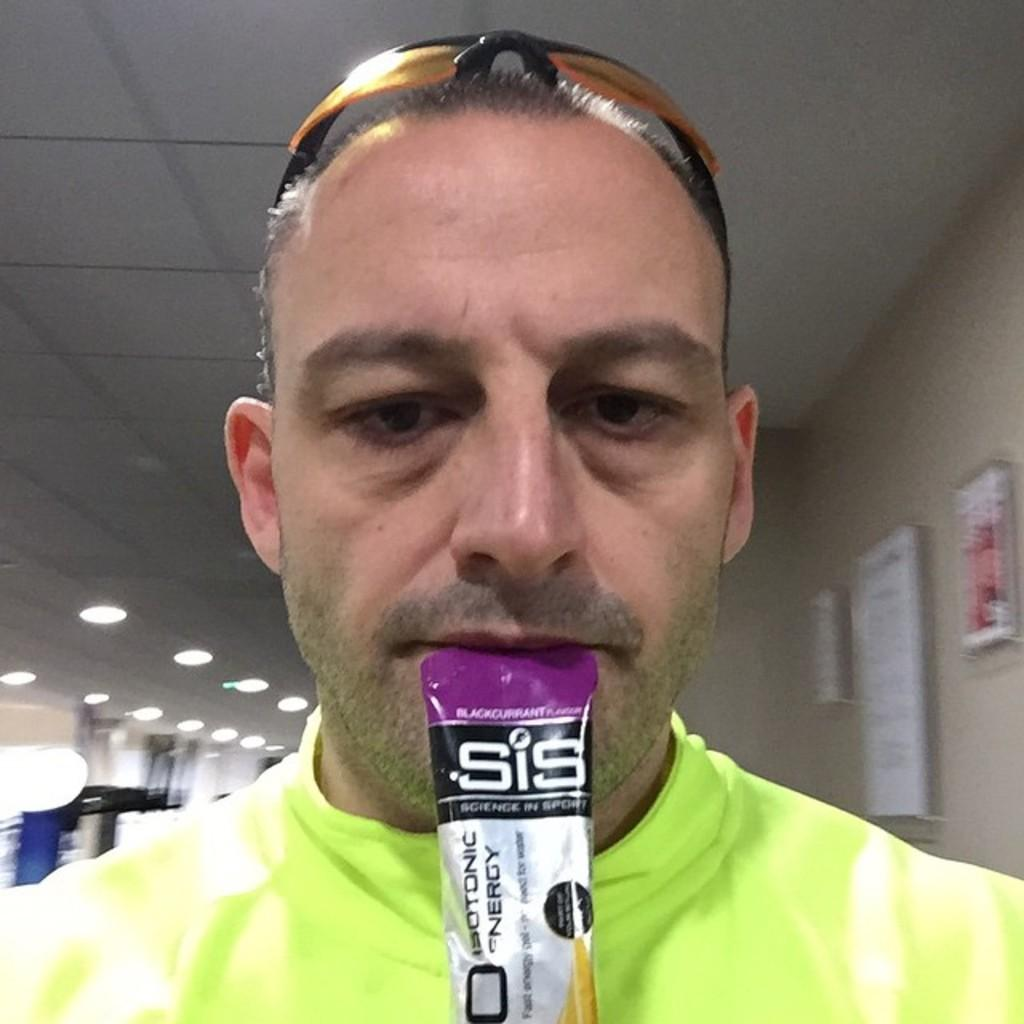What is the main subject of the image? There is a person in the image. What is the person wearing on their upper body? The person is wearing a green shirt. What type of protective eyewear is the person wearing? The person is wearing goggles. What can be seen on the wall behind the person? There are picture frames on the wall behind the person. What type of lighting is present in the image? There are lights attached to the roof in the image. What type of eggnog is being served in the image? There is no eggnog present in the image. How does the person in the image express disgust? The image does not show any expression of disgust by the person. Can you see any ladybugs in the image? There are no ladybugs present in the image. 